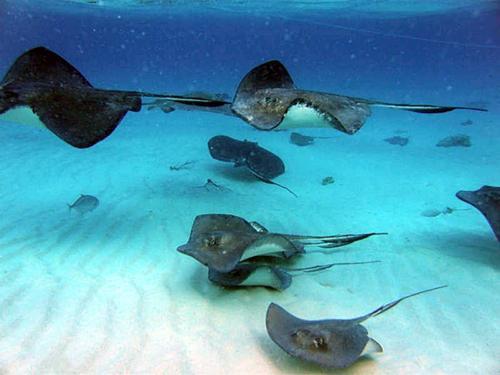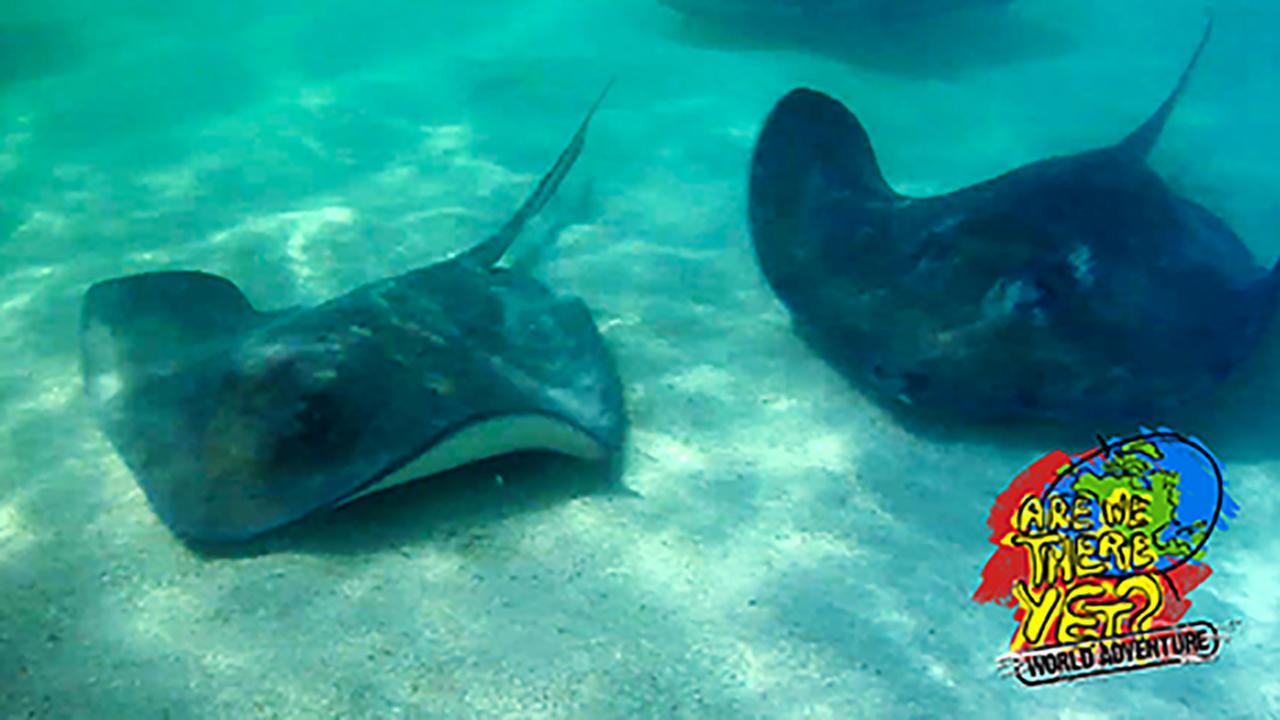The first image is the image on the left, the second image is the image on the right. Given the left and right images, does the statement "A person is touching a ray with their hand." hold true? Answer yes or no. No. The first image is the image on the left, the second image is the image on the right. Analyze the images presented: Is the assertion "The image on the left contains a persons hand stroking a small string ray." valid? Answer yes or no. No. 